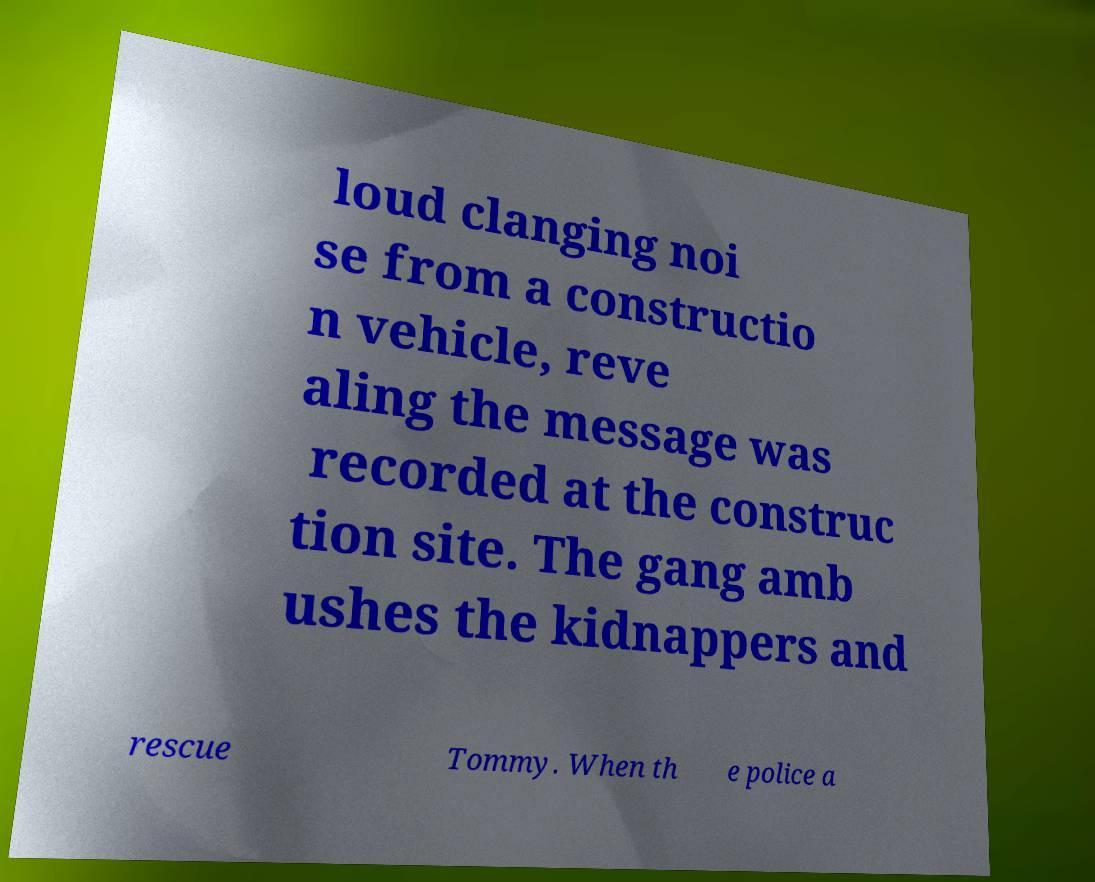What messages or text are displayed in this image? I need them in a readable, typed format. loud clanging noi se from a constructio n vehicle, reve aling the message was recorded at the construc tion site. The gang amb ushes the kidnappers and rescue Tommy. When th e police a 